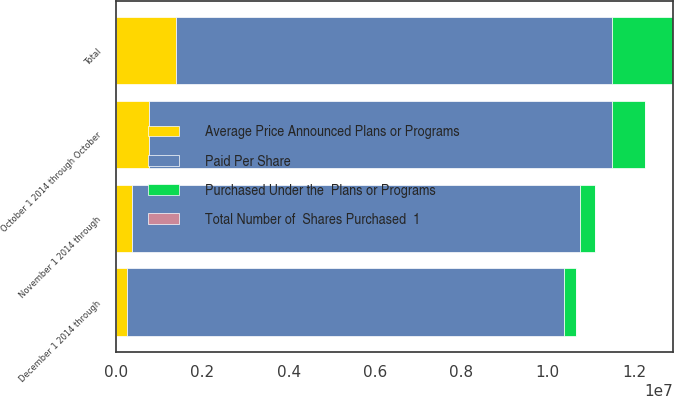<chart> <loc_0><loc_0><loc_500><loc_500><stacked_bar_chart><ecel><fcel>October 1 2014 through October<fcel>November 1 2014 through<fcel>December 1 2014 through<fcel>Total<nl><fcel>Purchased Under the  Plans or Programs<fcel>763915<fcel>362283<fcel>277231<fcel>1.40343e+06<nl><fcel>Total Number of  Shares Purchased  1<fcel>33.33<fcel>38.64<fcel>41.36<fcel>36.17<nl><fcel>Average Price Announced Plans or Programs<fcel>763915<fcel>362283<fcel>256490<fcel>1.38269e+06<nl><fcel>Paid Per Share<fcel>1.07375e+07<fcel>1.03752e+07<fcel>1.01187e+07<fcel>1.01187e+07<nl></chart> 